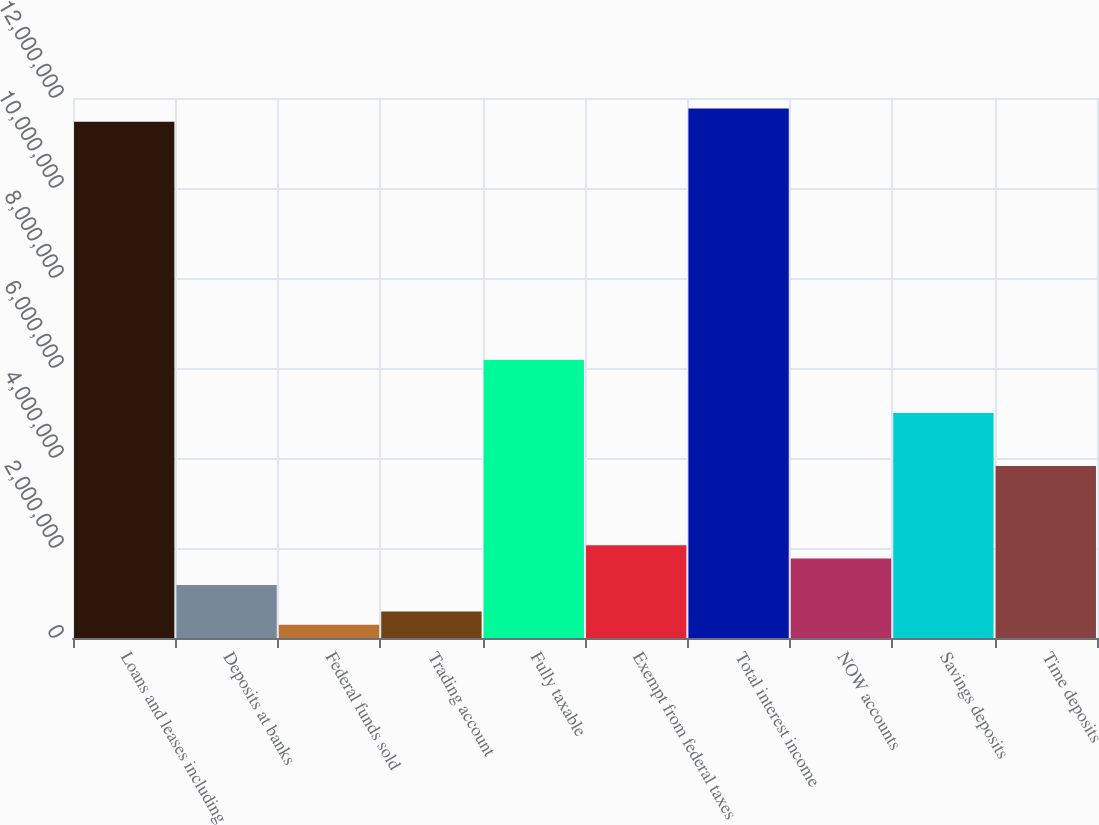Convert chart. <chart><loc_0><loc_0><loc_500><loc_500><bar_chart><fcel>Loans and leases including<fcel>Deposits at banks<fcel>Federal funds sold<fcel>Trading account<fcel>Fully taxable<fcel>Exempt from federal taxes<fcel>Total interest income<fcel>NOW accounts<fcel>Savings deposits<fcel>Time deposits<nl><fcel>1.14725e+07<fcel>1.17668e+06<fcel>294177<fcel>588344<fcel>6.17753e+06<fcel>2.05918e+06<fcel>1.17667e+07<fcel>1.76501e+06<fcel>5.00086e+06<fcel>3.82419e+06<nl></chart> 